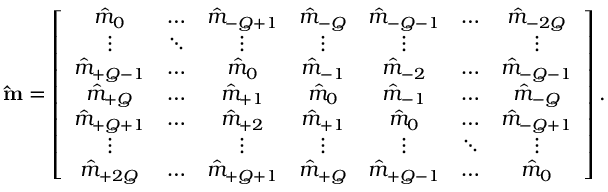<formula> <loc_0><loc_0><loc_500><loc_500>\hat { m } = \left [ \begin{array} { c c c c c c c } { \hat { m } _ { 0 } } & { \hdots } & { \hat { m } _ { - Q + 1 } } & { \hat { m } _ { - Q } } & { \hat { m } _ { - Q - 1 } } & { \hdots } & { \hat { m } _ { - 2 Q } } \\ { \vdots } & { \ddots } & { \vdots } & { \vdots } & { \vdots } & & { \vdots } \\ { \hat { m } _ { + Q - 1 } } & { \hdots } & { \hat { m } _ { 0 } } & { \hat { m } _ { - 1 } } & { \hat { m } _ { - 2 } } & { \hdots } & { \hat { m } _ { - Q - 1 } } \\ { \hat { m } _ { + Q } } & { \hdots } & { \hat { m } _ { + 1 } } & { \hat { m } _ { 0 } } & { \hat { m } _ { - 1 } } & { \hdots } & { \hat { m } _ { - Q } } \\ { \hat { m } _ { + Q + 1 } } & { \hdots } & { \hat { m } _ { + 2 } } & { \hat { m } _ { + 1 } } & { \hat { m } _ { 0 } } & { \hdots } & { \hat { m } _ { - Q + 1 } } \\ { \vdots } & & { \vdots } & { \vdots } & { \vdots } & { \ddots } & { \vdots } \\ { \hat { m } _ { + 2 Q } } & { \hdots } & { \hat { m } _ { + Q + 1 } } & { \hat { m } _ { + Q } } & { \hat { m } _ { + Q - 1 } } & { \hdots } & { \hat { m } _ { 0 } } \end{array} \right ] .</formula> 